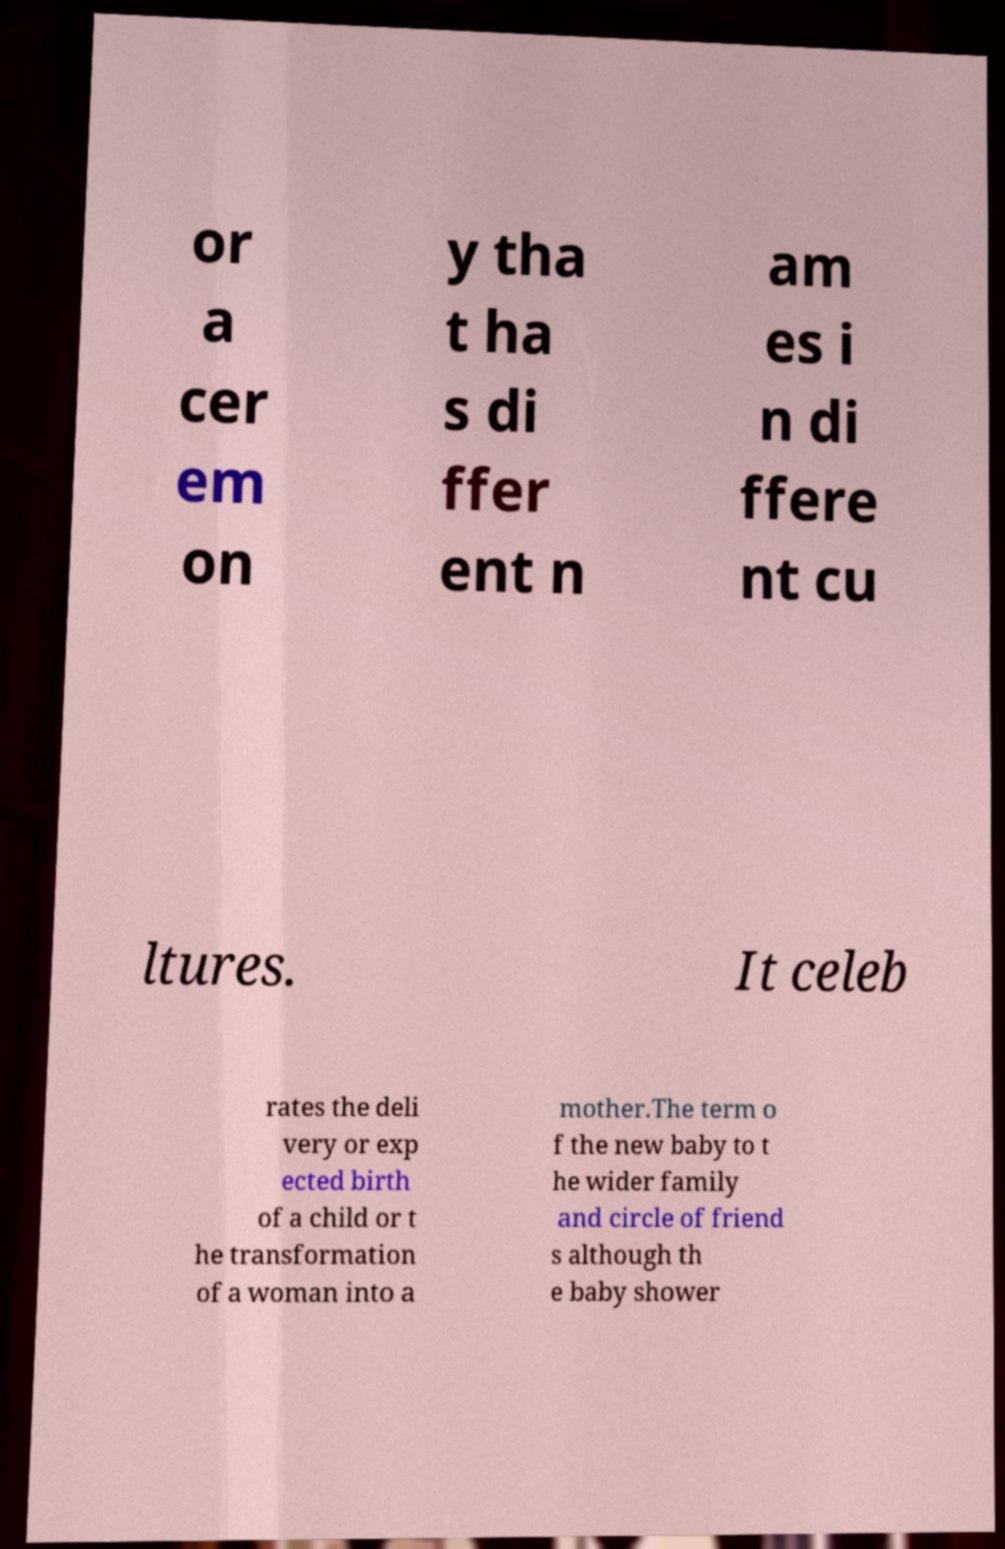Can you read and provide the text displayed in the image?This photo seems to have some interesting text. Can you extract and type it out for me? or a cer em on y tha t ha s di ffer ent n am es i n di ffere nt cu ltures. It celeb rates the deli very or exp ected birth of a child or t he transformation of a woman into a mother.The term o f the new baby to t he wider family and circle of friend s although th e baby shower 